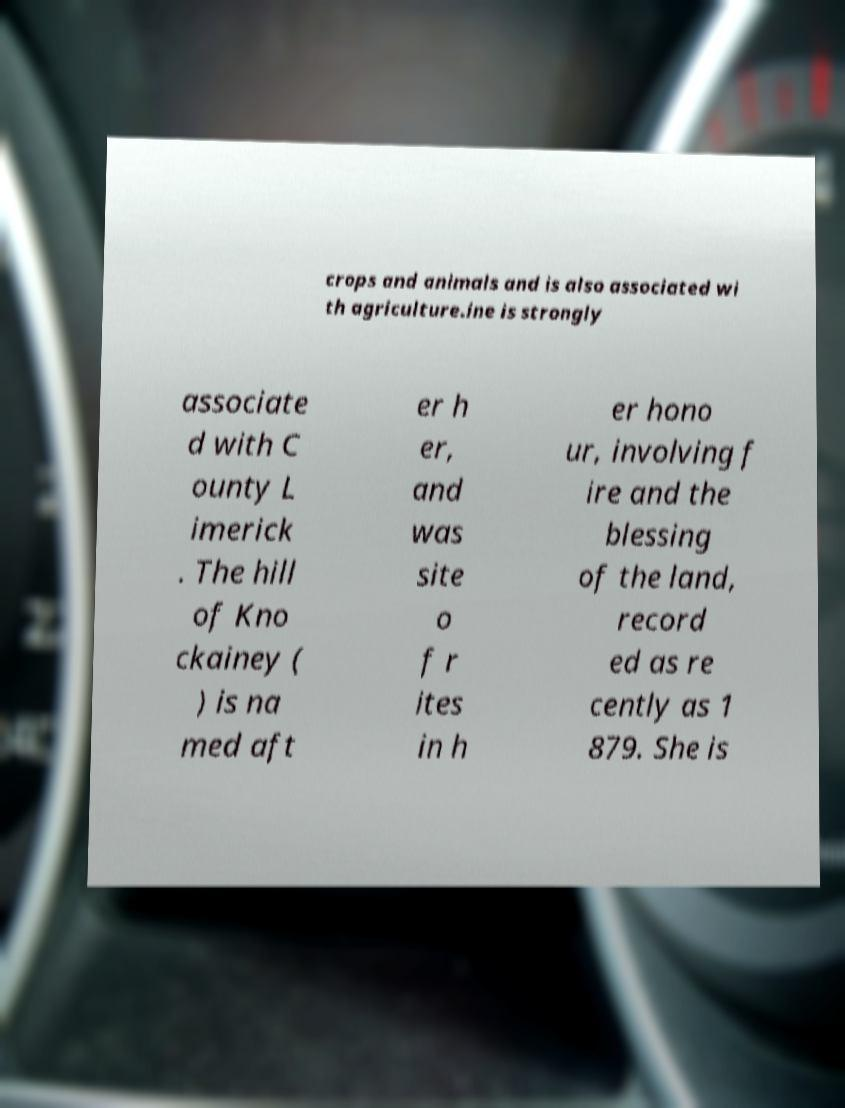Could you assist in decoding the text presented in this image and type it out clearly? crops and animals and is also associated wi th agriculture.ine is strongly associate d with C ounty L imerick . The hill of Kno ckainey ( ) is na med aft er h er, and was site o f r ites in h er hono ur, involving f ire and the blessing of the land, record ed as re cently as 1 879. She is 